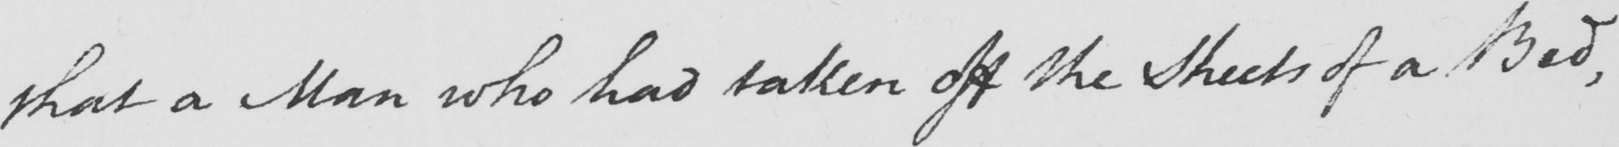What is written in this line of handwriting? that a Man who had taken off the Sheets of a Bed , 